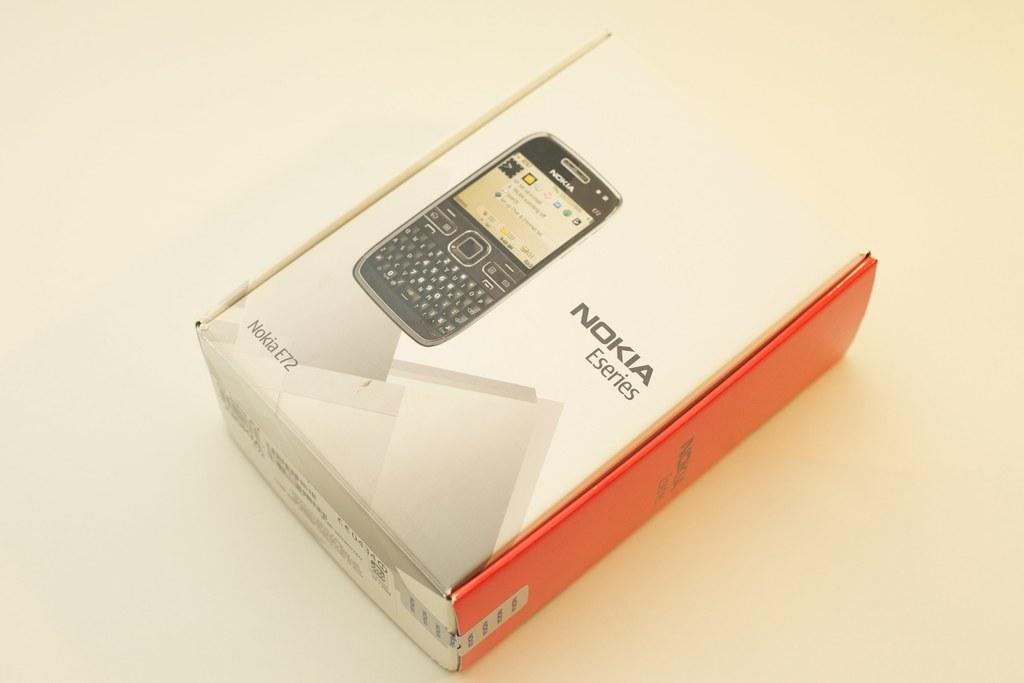<image>
Relay a brief, clear account of the picture shown. Nokia box with the phone featuring the Nokia E72 series. 